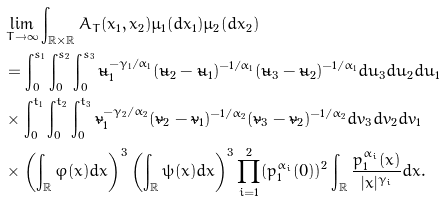<formula> <loc_0><loc_0><loc_500><loc_500>& \lim _ { T \to \infty } \int _ { \mathbb { R } \times \mathbb { R } } A _ { T } ( x _ { 1 } , x _ { 2 } ) \mu _ { 1 } ( d x _ { 1 } ) \mu _ { 2 } ( d x _ { 2 } ) \\ & = \int _ { 0 } ^ { s _ { 1 } } \int _ { 0 } ^ { s _ { 2 } } \int _ { 0 } ^ { s _ { 3 } } \tilde { u } _ { 1 } ^ { - \gamma _ { 1 } / \alpha _ { 1 } } ( \tilde { u } _ { 2 } - \tilde { u } _ { 1 } ) ^ { - 1 / \alpha _ { 1 } } ( \tilde { u } _ { 3 } - \tilde { u } _ { 2 } ) ^ { - 1 / \alpha _ { 1 } } d u _ { 3 } d u _ { 2 } d u _ { 1 } \\ & \times \int _ { 0 } ^ { t _ { 1 } } \int _ { 0 } ^ { t _ { 2 } } \int _ { 0 } ^ { t _ { 3 } } \tilde { v } _ { 1 } ^ { - \gamma _ { 2 } / \alpha _ { 2 } } ( \tilde { v } _ { 2 } - \tilde { v } _ { 1 } ) ^ { - 1 / \alpha _ { 2 } } ( \tilde { v } _ { 3 } - \tilde { v } _ { 2 } ) ^ { - 1 / \alpha _ { 2 } } d v _ { 3 } d v _ { 2 } d v _ { 1 } \\ & \times \left ( \int _ { \mathbb { R } } \varphi ( x ) d x \right ) ^ { 3 } \left ( \int _ { \mathbb { R } } \psi ( x ) d x \right ) ^ { 3 } \prod _ { i = 1 } ^ { 2 } ( p _ { 1 } ^ { \alpha _ { i } } ( 0 ) ) ^ { 2 } \int _ { \mathbb { R } } \frac { p _ { 1 } ^ { \alpha _ { i } } ( x ) } { | x | ^ { \gamma _ { i } } } d x .</formula> 